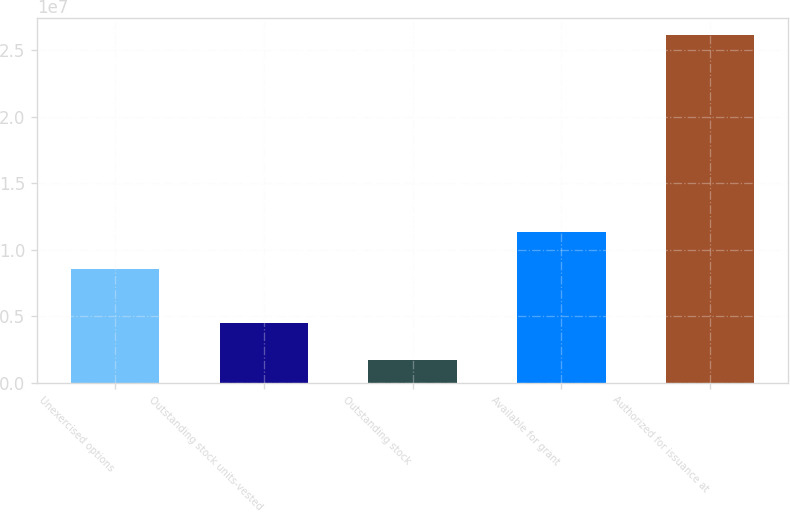Convert chart to OTSL. <chart><loc_0><loc_0><loc_500><loc_500><bar_chart><fcel>Unexercised options<fcel>Outstanding stock units-vested<fcel>Outstanding stock<fcel>Available for grant<fcel>Authorized for issuance at<nl><fcel>8.54922e+06<fcel>4.51249e+06<fcel>1.69244e+06<fcel>1.13637e+07<fcel>2.61179e+07<nl></chart> 